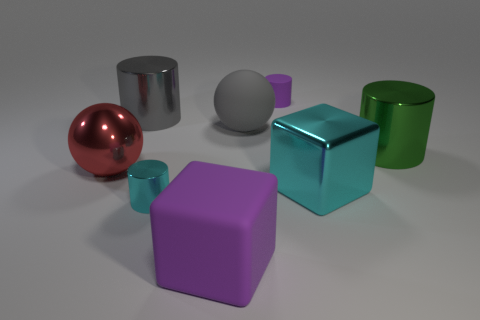There is a purple object that is the same shape as the large cyan object; what material is it?
Your answer should be very brief. Rubber. How many cylinders are either tiny rubber objects or big gray objects?
Offer a terse response. 2. How many cyan cubes are the same material as the green cylinder?
Make the answer very short. 1. Do the purple object behind the large red shiny ball and the purple object that is in front of the gray cylinder have the same material?
Make the answer very short. Yes. There is a matte cylinder to the right of the gray thing to the left of the tiny metallic object; how many big metal things are on the left side of it?
Your answer should be compact. 2. There is a large metal cylinder that is behind the gray rubber ball; is its color the same as the large cylinder that is on the right side of the cyan metal cylinder?
Make the answer very short. No. Are there any other things that have the same color as the large metallic cube?
Keep it short and to the point. Yes. There is a small cylinder behind the big shiny cylinder that is on the left side of the gray ball; what is its color?
Offer a very short reply. Purple. Are there any tiny purple metallic blocks?
Offer a very short reply. No. The big object that is in front of the red sphere and behind the tiny cyan metal thing is what color?
Your answer should be very brief. Cyan. 